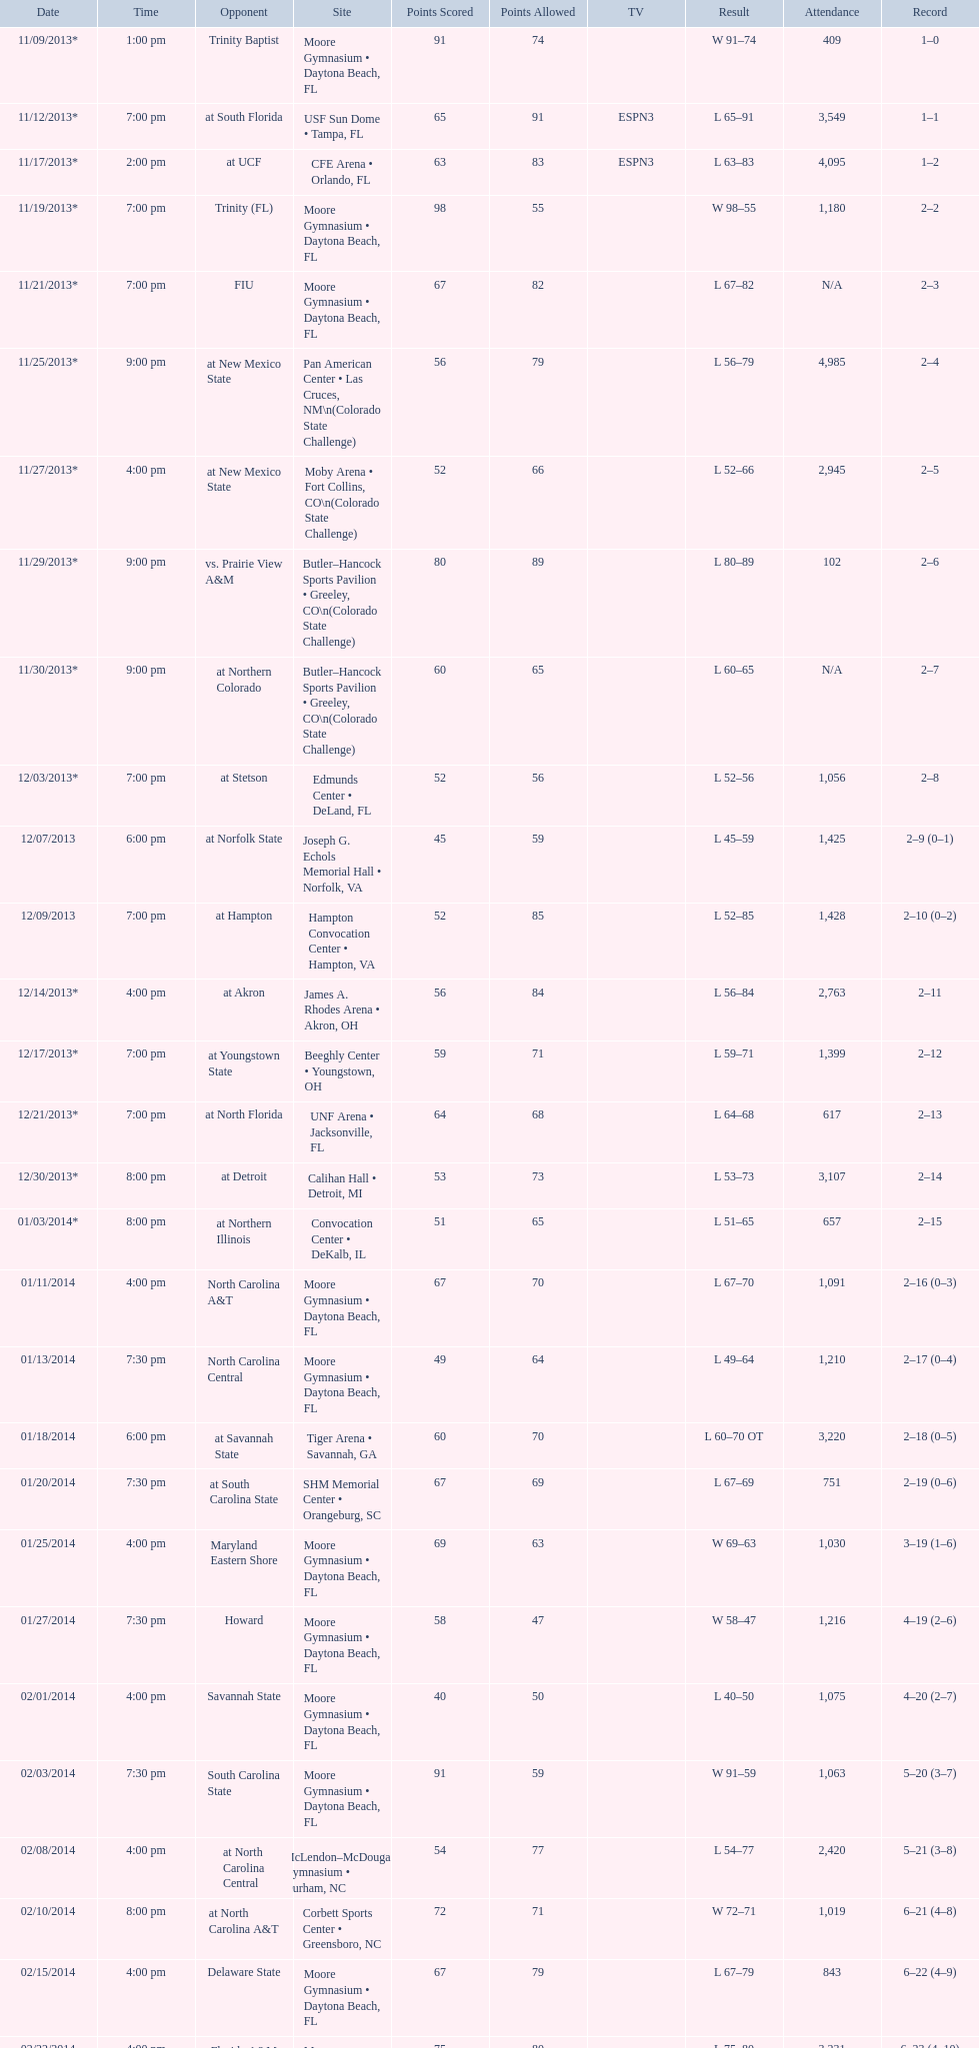How many teams had at most an attendance of 1,000? 6. 